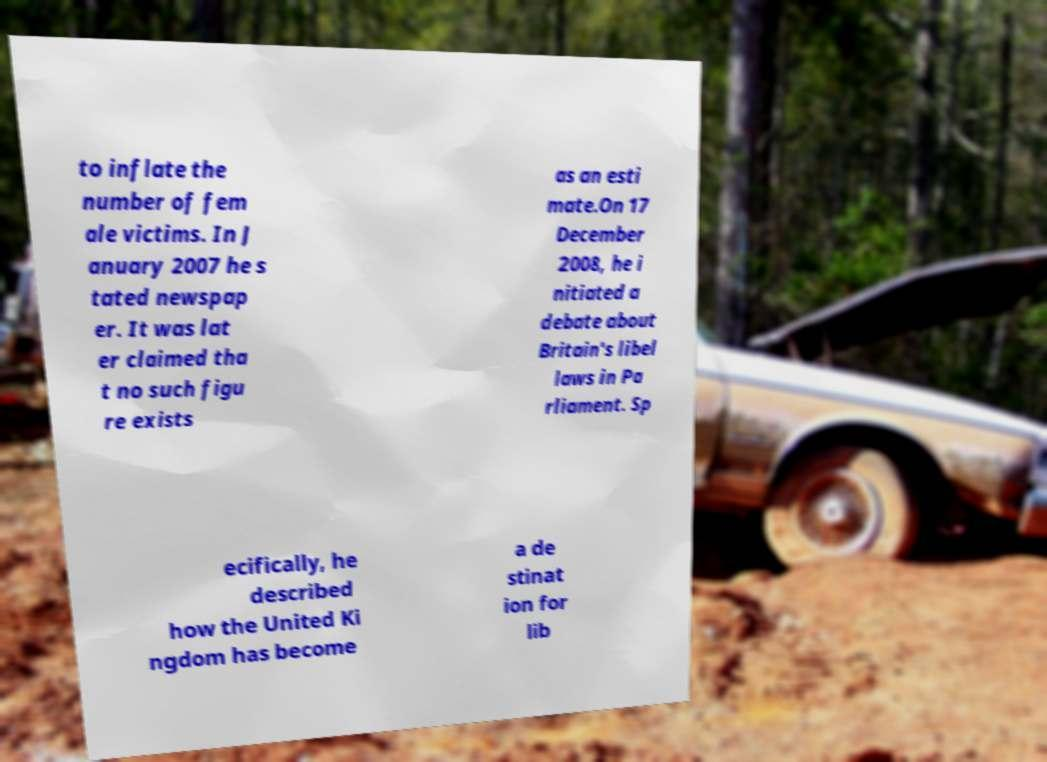Can you read and provide the text displayed in the image?This photo seems to have some interesting text. Can you extract and type it out for me? to inflate the number of fem ale victims. In J anuary 2007 he s tated newspap er. It was lat er claimed tha t no such figu re exists as an esti mate.On 17 December 2008, he i nitiated a debate about Britain's libel laws in Pa rliament. Sp ecifically, he described how the United Ki ngdom has become a de stinat ion for lib 